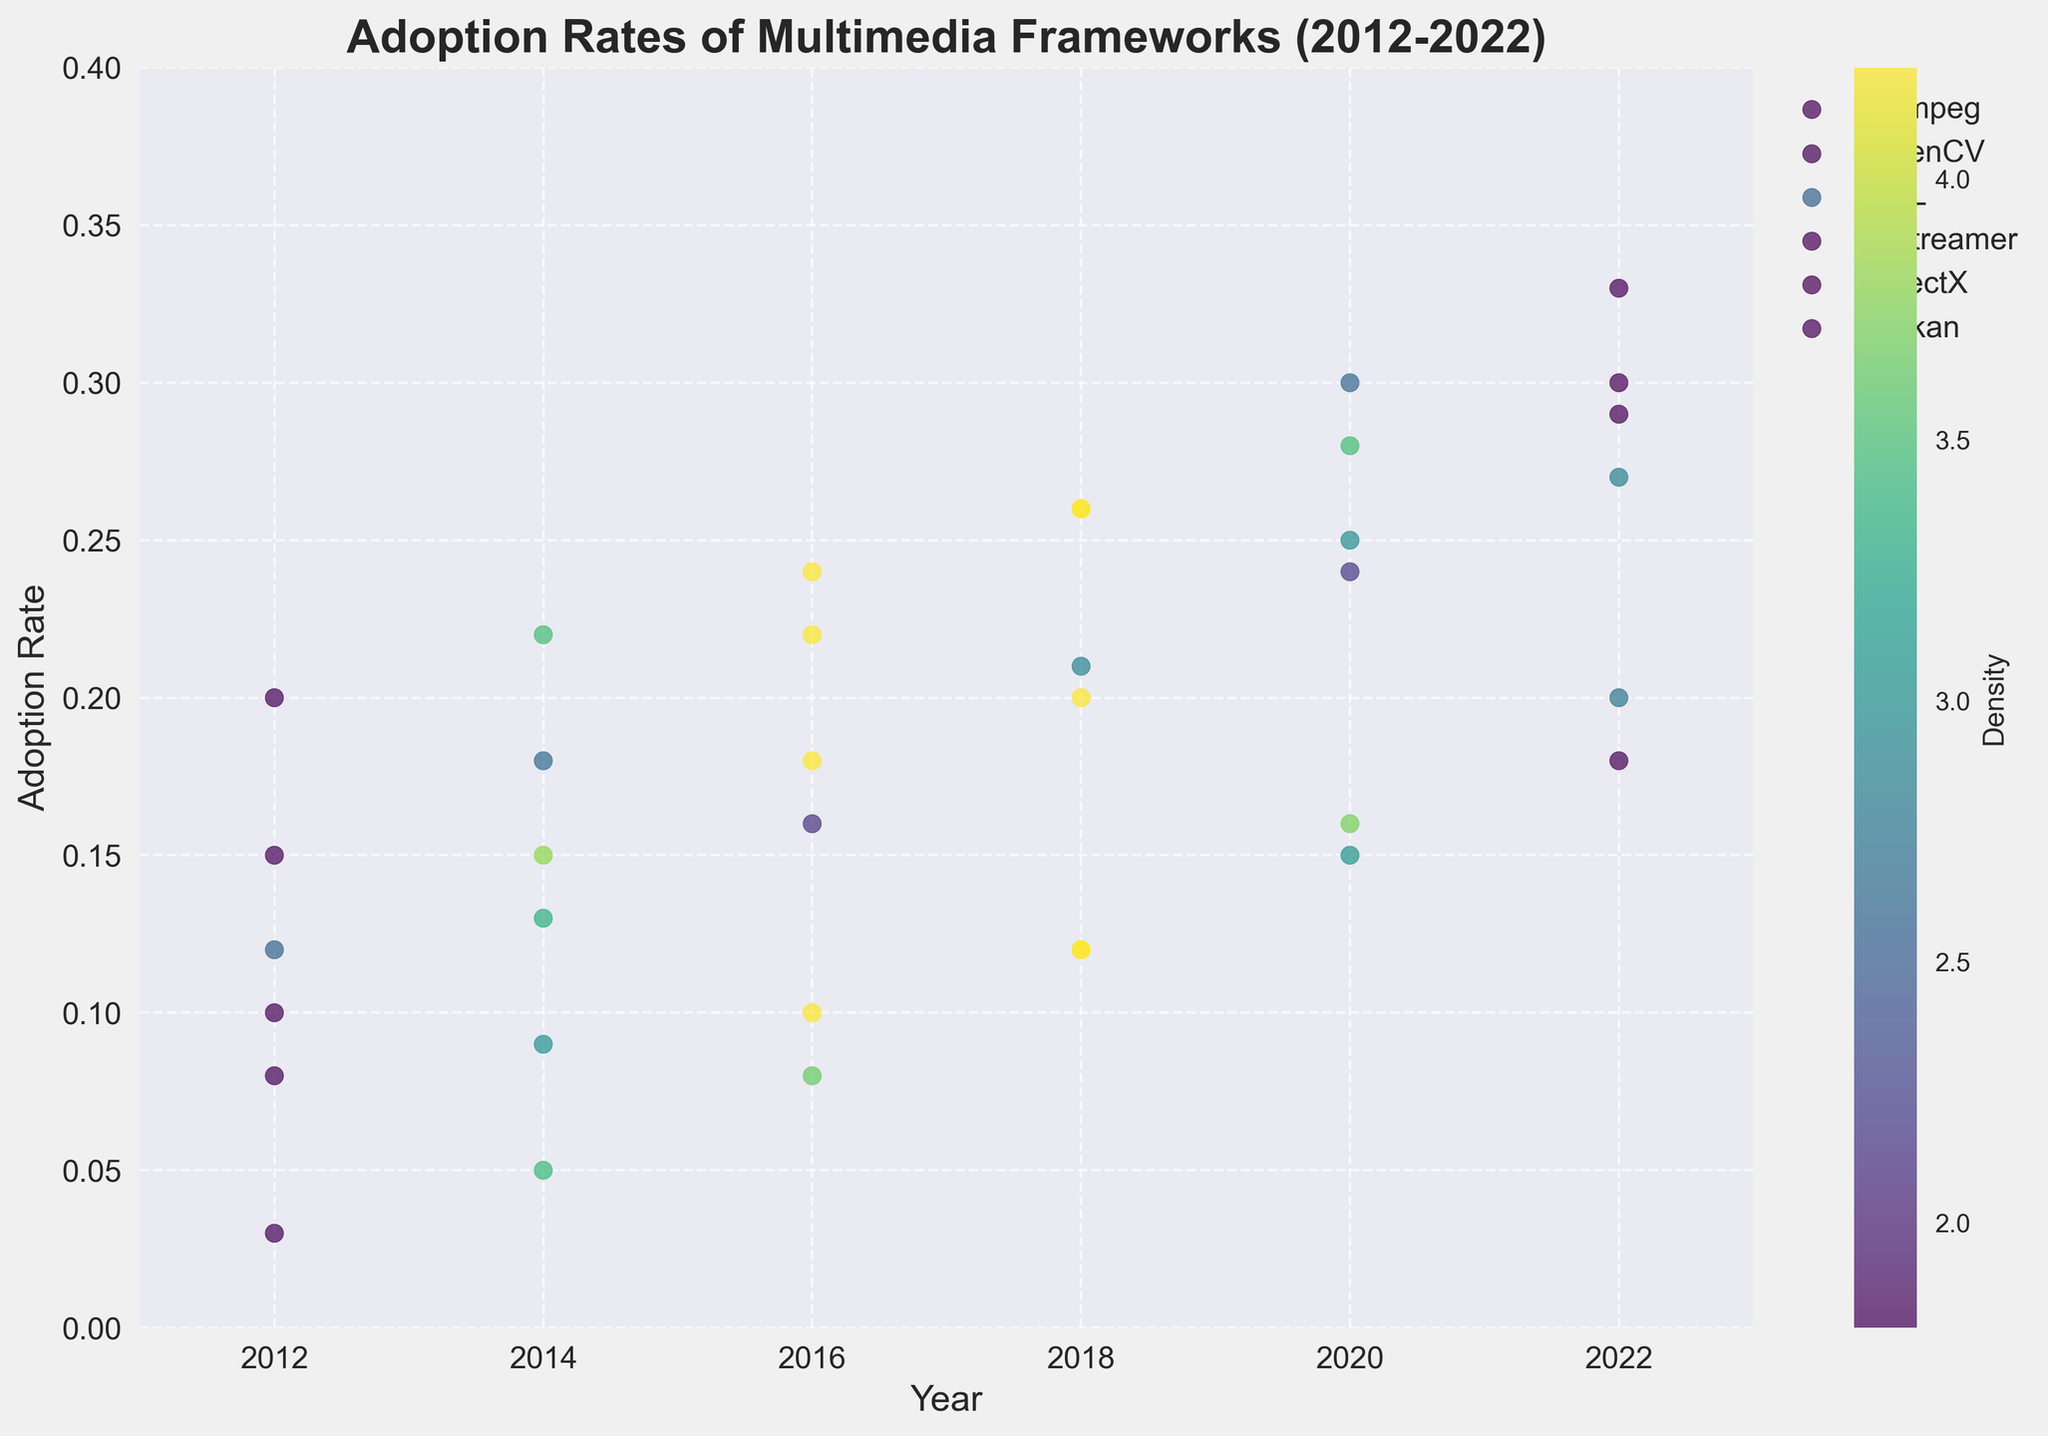Which year had the highest adoption rate for FFmpeg? According to the density plot, the year 2022 shows the highest adoption rate for FFmpeg, which is around 0.33.
Answer: 2022 What is the adoption rate of DirectX in 2020? The density plot shows that the adoption rate for DirectX in 2020 is approximately 0.28.
Answer: 0.28 Which multimedia library had the lowest adoption rate in 2012? By comparing all the plots, Vulkan had the lowest adoption rate in 2012, which is around 0.03.
Answer: Vulkan How did the adoption rate of OpenCV change from 2014 to 2018? In 2014, the adoption rate of OpenCV was around 0.13, and in 2018 it increased to approximately 0.20. Therefore, the adoption rate increased by about 0.07.
Answer: Increased by 0.07 Compare the adoption rates of GStreamer and SDL in 2018. According to the plot, the adoption rate of GStreamer in 2018 is around 0.12, and for SDL, it is around 0.21. Therefore, SDL had a higher adoption rate than GStreamer in 2018.
Answer: SDL had a higher rate What trend in the adoption rate of FFmpeg do you observe between 2012 and 2022? The density plot reveals that the adoption rate of FFmpeg consistently increased from around 0.15 in 2012 to approximately 0.33 in 2022. This shows a steady upward trend over the decade.
Answer: Upward trend Between which two consecutive years did Vulkan see the most significant increase in adoption rate? Analyzing the plot, the most significant increase for Vulkan is observed between 2018 (0.12) and 2020 (0.16), which is an increment of about 0.04.
Answer: Between 2018 and 2020 Which library had the most significant increase in adoption rate from 2016 to 2020? Examining the plot, OpenCV had an adoption rate increase from 0.16 in 2016 to 0.24 in 2020, resulting in an increase of 0.08, the largest increment among the libraries during that period.
Answer: OpenCV Rank the libraries by their adoption rates in 2022. In 2022, the adoption rates from highest to lowest are: FFmpeg (0.33), DirectX (0.30), SDL (0.29), OpenCV (0.27), Vulkan (0.20), and GStreamer (0.18).
Answer: FFmpeg, DirectX, SDL, OpenCV, Vulkan, GStreamer What is the range of adoption rates for GStreamer from 2012 to 2022? From the plots, GStreamer's lowest adoption rate over the years was in 2012 (0.08) and its highest was in 2022 (0.18). The range is calculated as 0.18 - 0.08.
Answer: 0.10 